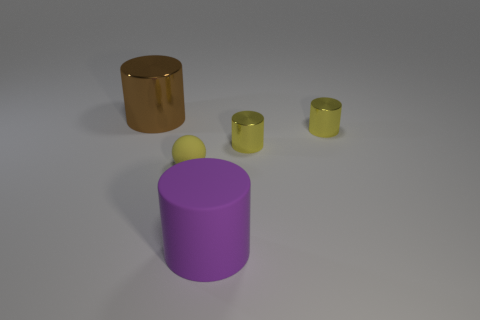What number of things have the same color as the matte sphere?
Your answer should be very brief. 2. There is a metal cylinder that is on the left side of the small matte ball; how big is it?
Your answer should be compact. Large. What number of yellow spheres have the same size as the brown shiny cylinder?
Give a very brief answer. 0. What color is the large object that is the same material as the yellow ball?
Ensure brevity in your answer.  Purple. Is the number of tiny yellow objects that are in front of the rubber cylinder less than the number of small yellow balls?
Provide a succinct answer. Yes. There is a purple thing that is the same material as the tiny yellow sphere; what is its shape?
Provide a short and direct response. Cylinder. How many metal things are small brown things or yellow things?
Give a very brief answer. 2. Are there an equal number of spheres behind the yellow matte sphere and brown things?
Offer a very short reply. No. There is a large cylinder that is to the right of the tiny yellow ball; does it have the same color as the big metallic cylinder?
Offer a terse response. No. What material is the object that is both right of the large brown cylinder and on the left side of the large purple matte cylinder?
Your answer should be compact. Rubber. 